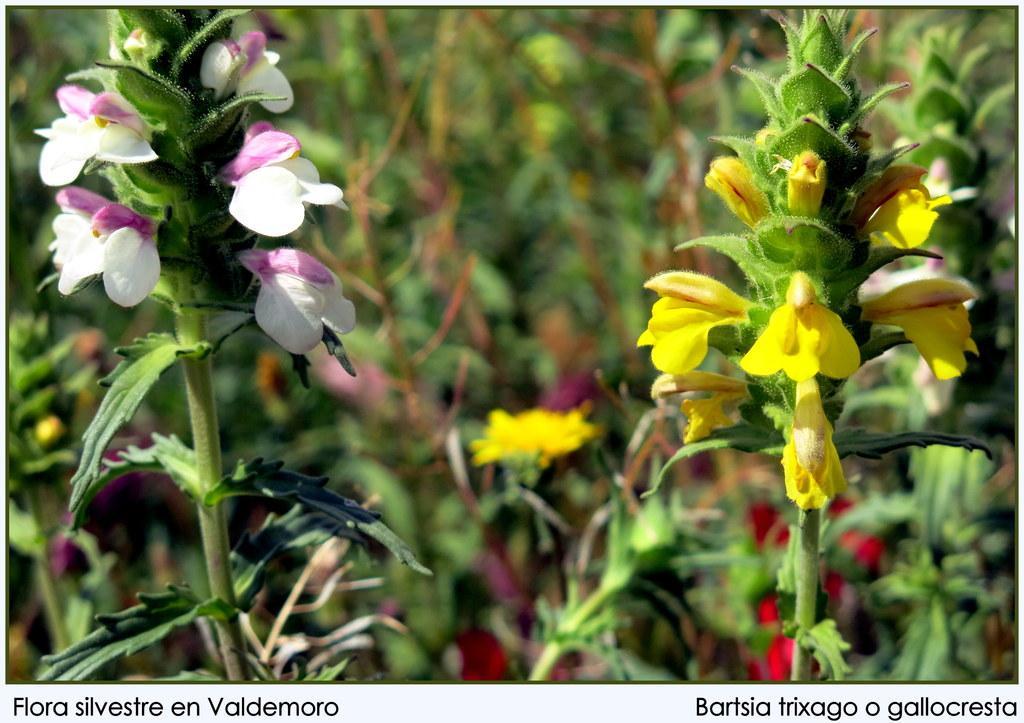Please provide a concise description of this image. On the bottom left, there is a watermark. On the left side, there is a plant having flowers and leaves. On the bottom right, there is a watermark. On the right side, there is a plant having flowers. In the background, there are other plants. 